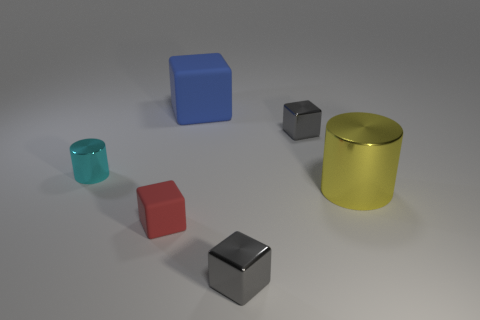Is the size of the cyan metal object the same as the blue matte cube?
Make the answer very short. No. There is a cube that is in front of the blue thing and behind the red rubber block; what is its size?
Your answer should be very brief. Small. What number of cyan objects have the same material as the large blue cube?
Give a very brief answer. 0. The tiny rubber cube has what color?
Keep it short and to the point. Red. There is a gray metallic object in front of the small red object; is its shape the same as the small red matte thing?
Give a very brief answer. Yes. What number of objects are cubes on the left side of the big matte thing or metallic objects?
Provide a succinct answer. 5. Is there another yellow object of the same shape as the large yellow thing?
Your response must be concise. No. What is the shape of the other thing that is the same size as the yellow metallic object?
Keep it short and to the point. Cube. What is the shape of the gray object that is to the right of the gray metal block that is on the left side of the gray cube behind the small red matte object?
Your answer should be very brief. Cube. Does the tiny cyan metallic object have the same shape as the tiny gray metallic thing that is behind the red object?
Give a very brief answer. No. 